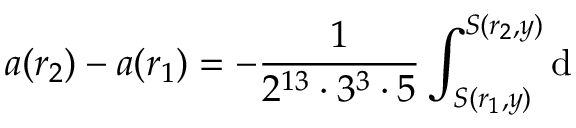Convert formula to latex. <formula><loc_0><loc_0><loc_500><loc_500>a ( r _ { 2 } ) - a ( r _ { 1 } ) = - \frac { 1 } { 2 ^ { 1 3 } \cdot 3 ^ { 3 } \cdot 5 } \int _ { S ( r _ { 1 } , y ) } ^ { S ( r _ { 2 } , y ) } d</formula> 